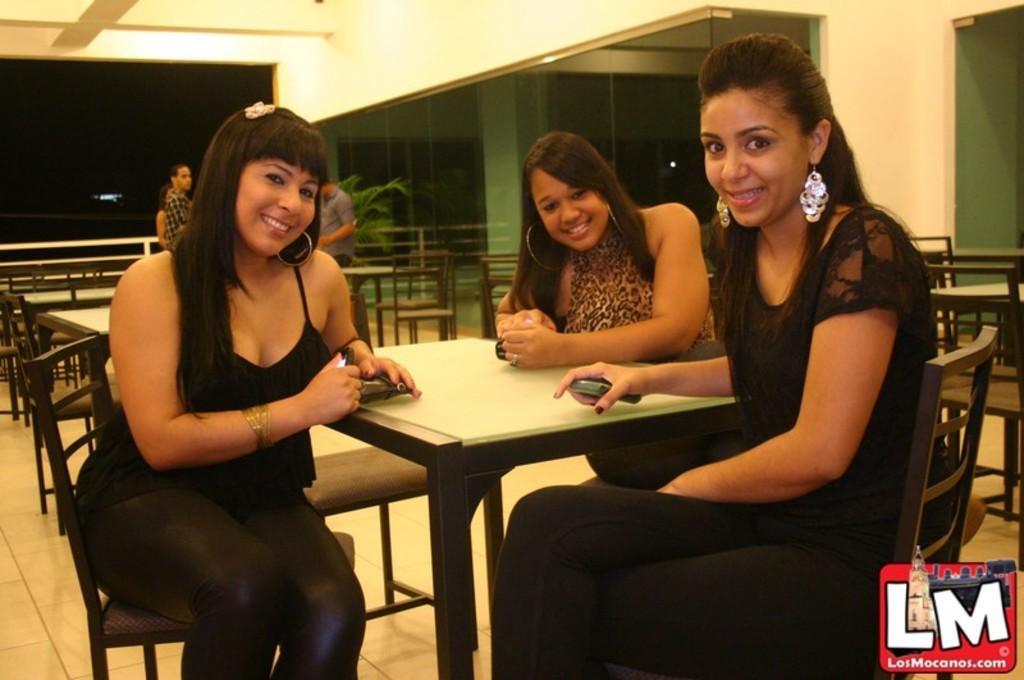Please provide a concise description of this image. Here we can see three women are sitting on the chairs. These are the tables. This is floor. Here we can see some persons standing on the floor. This is a pillar and there are lights. And this is wall. 